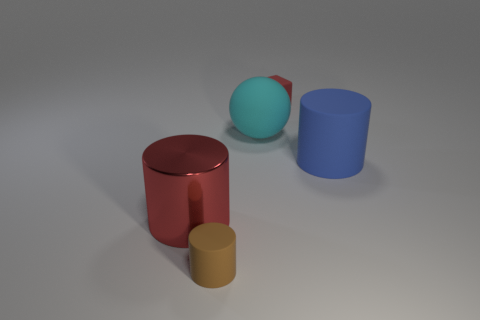Subtract all big shiny cylinders. How many cylinders are left? 2 Add 3 small blue shiny cylinders. How many objects exist? 8 Subtract all red cylinders. How many cylinders are left? 2 Subtract all spheres. How many objects are left? 4 Subtract all purple cylinders. Subtract all blue blocks. How many cylinders are left? 3 Subtract all green balls. How many red cylinders are left? 1 Subtract all large yellow things. Subtract all brown matte cylinders. How many objects are left? 4 Add 5 blue cylinders. How many blue cylinders are left? 6 Add 2 large matte balls. How many large matte balls exist? 3 Subtract 1 blue cylinders. How many objects are left? 4 